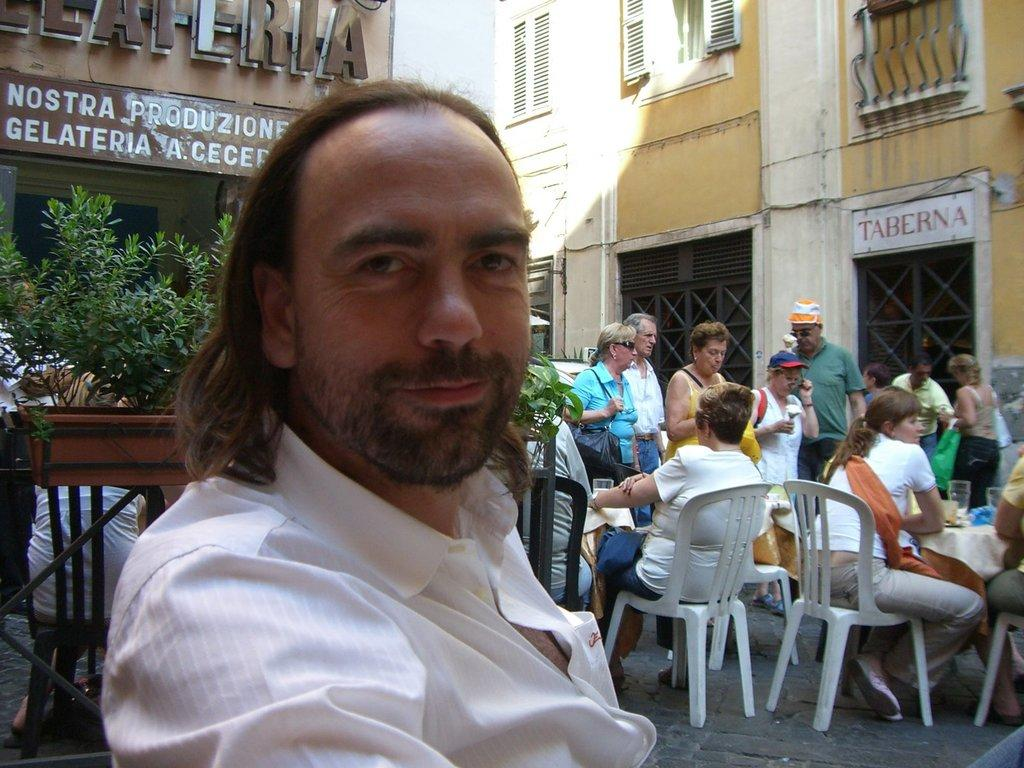Who is on the left side of the image? There is a man on the left side of the image. What is behind the man? There are plants behind the man. What type of structures can be seen in the image? There are buildings visible in the image. What architectural feature is present in the image? Windows are present in the image. What are some people doing in the image? Some people are sitting at a table, while others are standing. What objects are on the table? There are glasses on the table. How many oranges are being sold by the beggar in the image? There is no beggar or oranges present in the image. What type of bridge can be seen in the image? There is no bridge present in the image. 